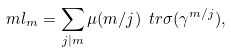Convert formula to latex. <formula><loc_0><loc_0><loc_500><loc_500>m l _ { m } = \sum _ { j | m } \mu ( m / j ) \ t r \sigma ( \gamma ^ { m / j } ) ,</formula> 